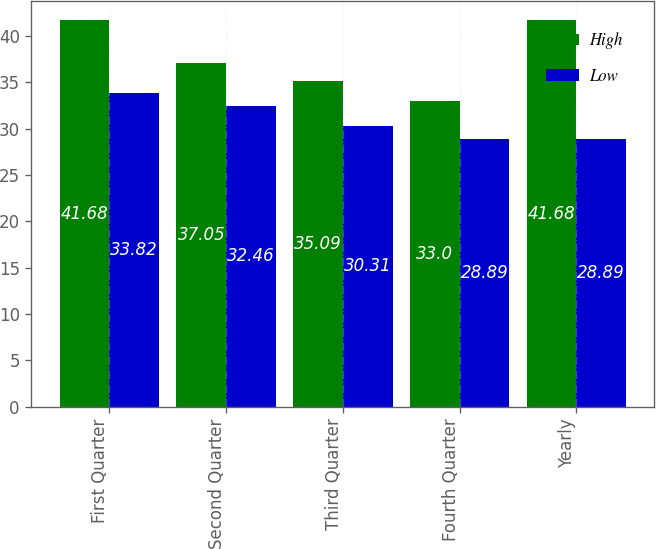Convert chart to OTSL. <chart><loc_0><loc_0><loc_500><loc_500><stacked_bar_chart><ecel><fcel>First Quarter<fcel>Second Quarter<fcel>Third Quarter<fcel>Fourth Quarter<fcel>Yearly<nl><fcel>High<fcel>41.68<fcel>37.05<fcel>35.09<fcel>33<fcel>41.68<nl><fcel>Low<fcel>33.82<fcel>32.46<fcel>30.31<fcel>28.89<fcel>28.89<nl></chart> 